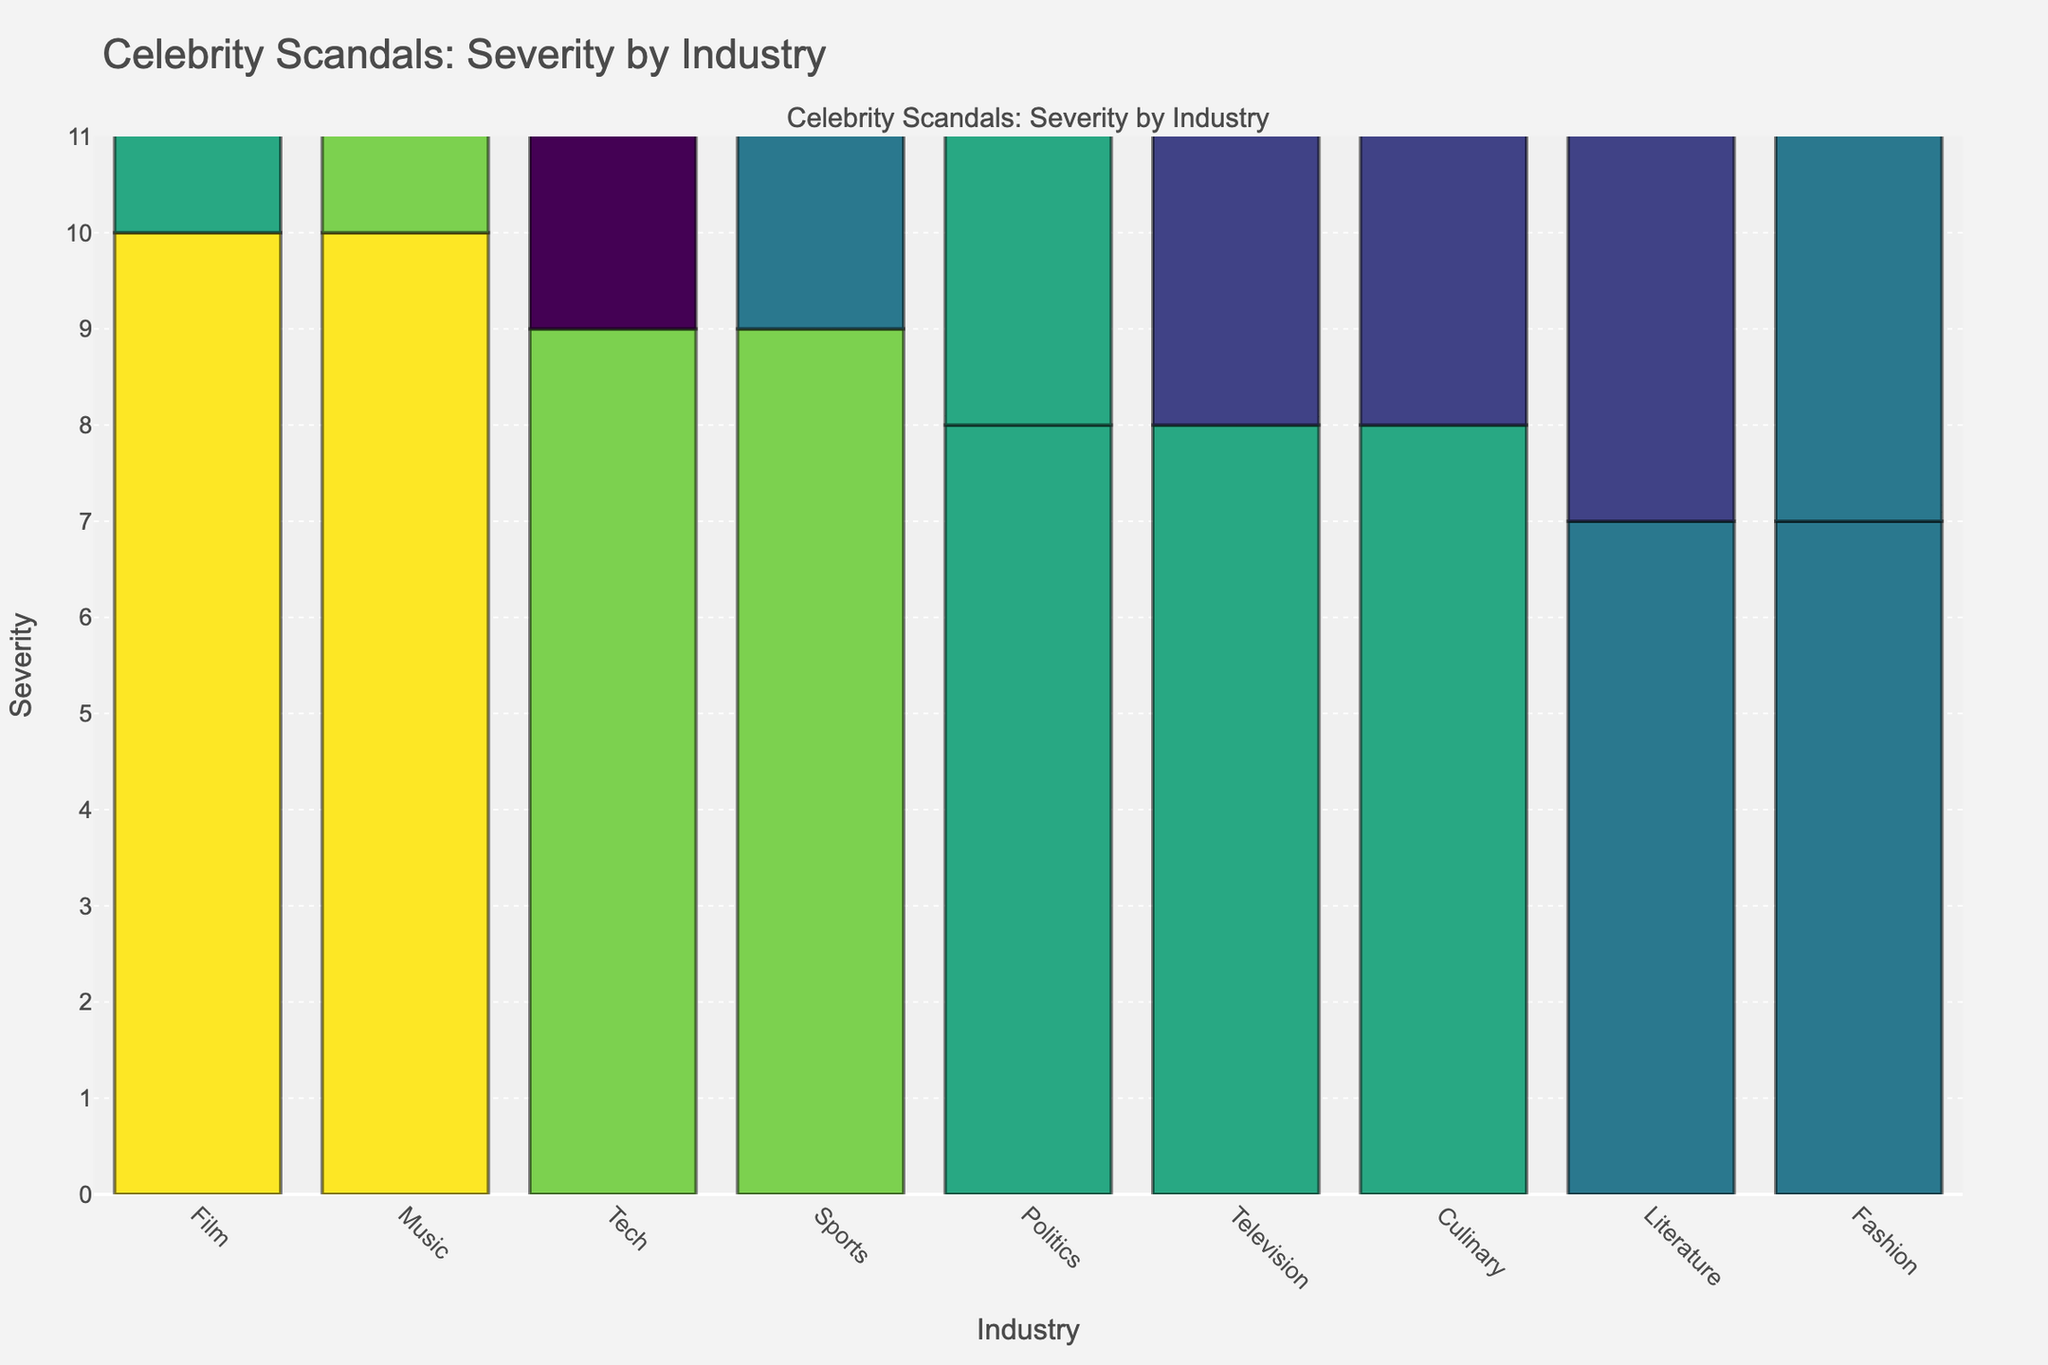Which industry has the highest severity scandal? The bar chart sorts the scandals by severity in descending order, with the highest bar on the left indicating the highest severity. The 'Music' industry is the first and has the 'R. Kelly sexual abuse allegations' scandal with severity 10.
Answer: Music What's the difference in severity between the highest and lowest scandals? The highest severity is 10 (R. Kelly sexual abuse allegations) and the lowest is 5 (Elon Musk marijuana incident). The difference is 10 - 5 = 5.
Answer: 5 Which scandal in the Film industry has the highest severity? The Film industry's bars show 'Harvey Weinstein sexual assault' and 'Mel Gibson antisemitic rant'. The tallest bar is for 'Harvey Weinstein sexual assault', with severity 10.
Answer: Harvey Weinstein sexual assault What is the average severity of scandals in the Politics industry? The Politics industry has 'Anthony Weiner sexting' (8) and 'Bill Clinton-Monica Lewinsky affair' (8). The average is (8 + 8) / 2 = 8.
Answer: 8 How many industries have scandals with severity 7? The bars with severity 7 are labeled 'Tiger Woods infidelity', 'John Galliano racist rant', 'J.K. Rowling transphobic tweets', 'Dolce & Gabbana racist ad campaign', and 'Britney Spears public meltdown', which belong to Music, Fashion, Sports, Literature, and Fashion. There are 5 industries.
Answer: 5 Which has the higher severity, 'Tile Zuckerberg data privacy scandal' or 'Paula Deen racial discrimination' scandal? By comparing the height of bars labeled 'Mark Zuckerberg data privacy scandal' (9) and 'Paula Deen racial discrimination' (6), it's clear that 'Mark Zuckerberg data privacy scandal' has a higher severity.
Answer: Mark Zuckerberg data privacy scandal Which industry has the most scandals listed? To determine this, count the bars for each industry: Music (3: Kanye West, R. Kelly, Britney Spears), Film (3: Will Smith, Harvey Weinstein, Mel Gibson), others vary. The Music and Film industries have 3 scandals each.
Answer: Music and Film What's the combined severity of all scandals in the Culinary industry? The Culinary industry has 'Paula Deen racial discrimination' (6) and 'Mario Batali sexual harassment' (8). The combined severity is 6 + 8 = 14.
Answer: 14 How does the severity of 'Ellen DeGeneres toxic workplace' compare to 'Tiger Woods infidelity'? Compare the heights of 'Ellen DeGeneres toxic workplace' (6) and 'Tiger Woods infidelity' (7). 'Tiger Woods infidelity' is higher, indicating greater severity.
Answer: Tiger Woods infidelity What is the total number of scandals with severity 8 and above? Count the bars with severity 8 and above: 'Harvey Weinstein sexual assault' (10), 'R. Kelly sexual abuse allegations' (10), 'Mark Zuckerberg data privacy scandal' (9), 'Kanye West antisemitic comments' (9), 'Lance Armstrong doping' (9), 'Will Smith Oscars slap' (8), 'Anthony Weiner sexting' (8), 'Bill Clinton-Monica Lewinsky affair' (8), 'Roseanne Barr racist tweet' (8), 'Mario Batali sexual harassment' (8), 'Mel Gibson antisemitic rant' (8). Total is 11.
Answer: 11 